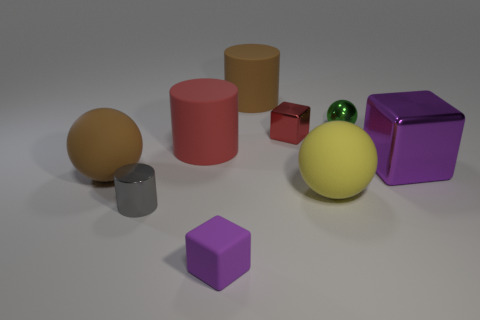Add 1 rubber cylinders. How many objects exist? 10 Subtract all cylinders. How many objects are left? 6 Add 4 purple cubes. How many purple cubes are left? 6 Add 4 big gray shiny cylinders. How many big gray shiny cylinders exist? 4 Subtract 0 purple balls. How many objects are left? 9 Subtract all big purple metal cylinders. Subtract all small blocks. How many objects are left? 7 